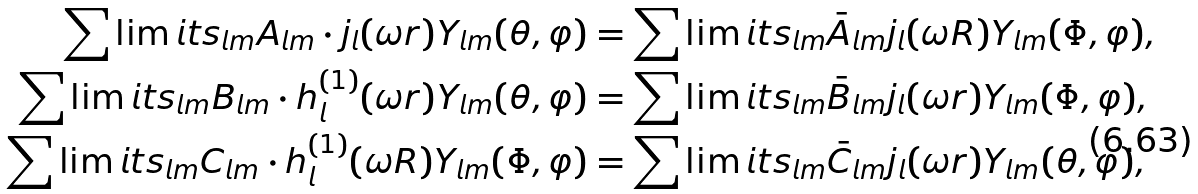<formula> <loc_0><loc_0><loc_500><loc_500>\sum \lim i t s _ { l m } A _ { l m } \cdot j _ { l } ( \omega r ) Y _ { l m } ( \theta , \varphi ) & = \sum \lim i t s _ { l m } \bar { A } _ { l m } j _ { l } ( \omega R ) Y _ { l m } ( \Phi , \varphi ) , \\ \sum \lim i t s _ { l m } B _ { l m } \cdot h _ { l } ^ { ( 1 ) } ( \omega r ) Y _ { l m } ( \theta , \varphi ) & = \sum \lim i t s _ { l m } \bar { B } _ { l m } j _ { l } ( \omega r ) Y _ { l m } ( \Phi , \varphi ) , \\ \sum \lim i t s _ { l m } C _ { l m } \cdot h _ { l } ^ { ( 1 ) } ( \omega R ) Y _ { l m } ( \Phi , \varphi ) & = \sum \lim i t s _ { l m } \bar { C } _ { l m } j _ { l } ( \omega r ) Y _ { l m } ( \theta , \varphi ) ,</formula> 